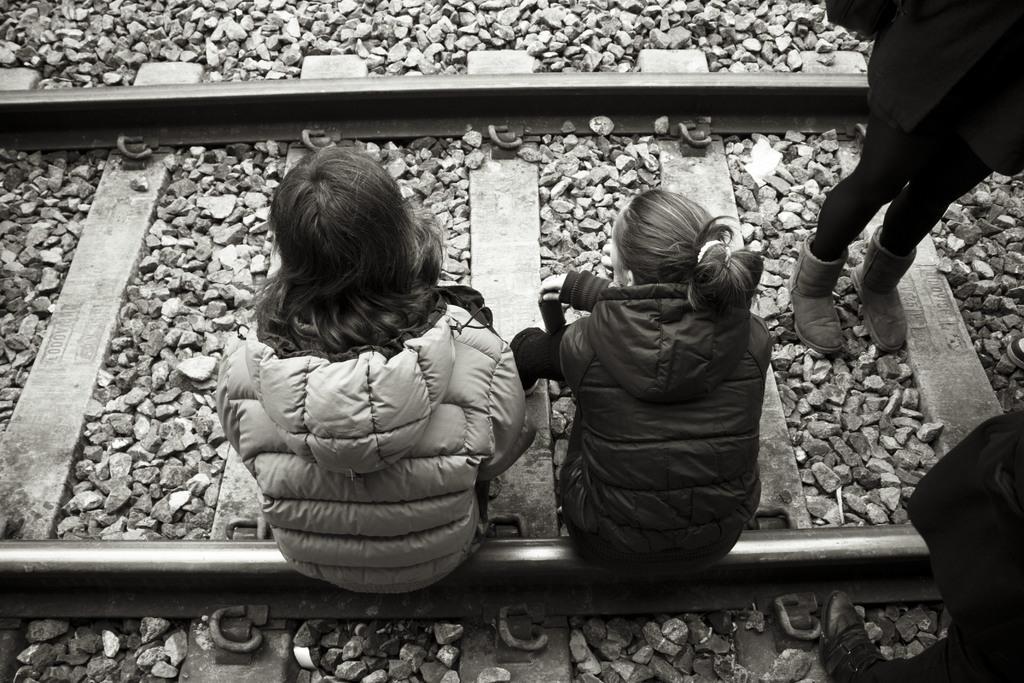Could you give a brief overview of what you see in this image? In this image there are two persons are sitting on a railway track in the bottom of this image, and there are two persons are standing on the right side of this image. There is a railway track in middle of this image and there are some stones are in the background. 